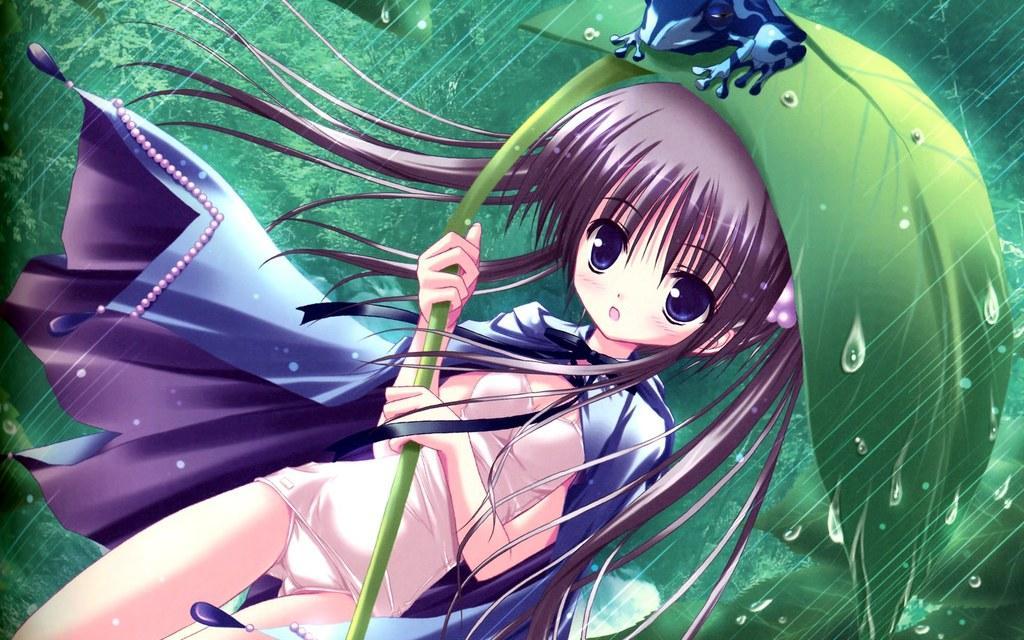How would you summarize this image in a sentence or two? In this image we can see there is an animation of a girl holding a leaf umbrella. 